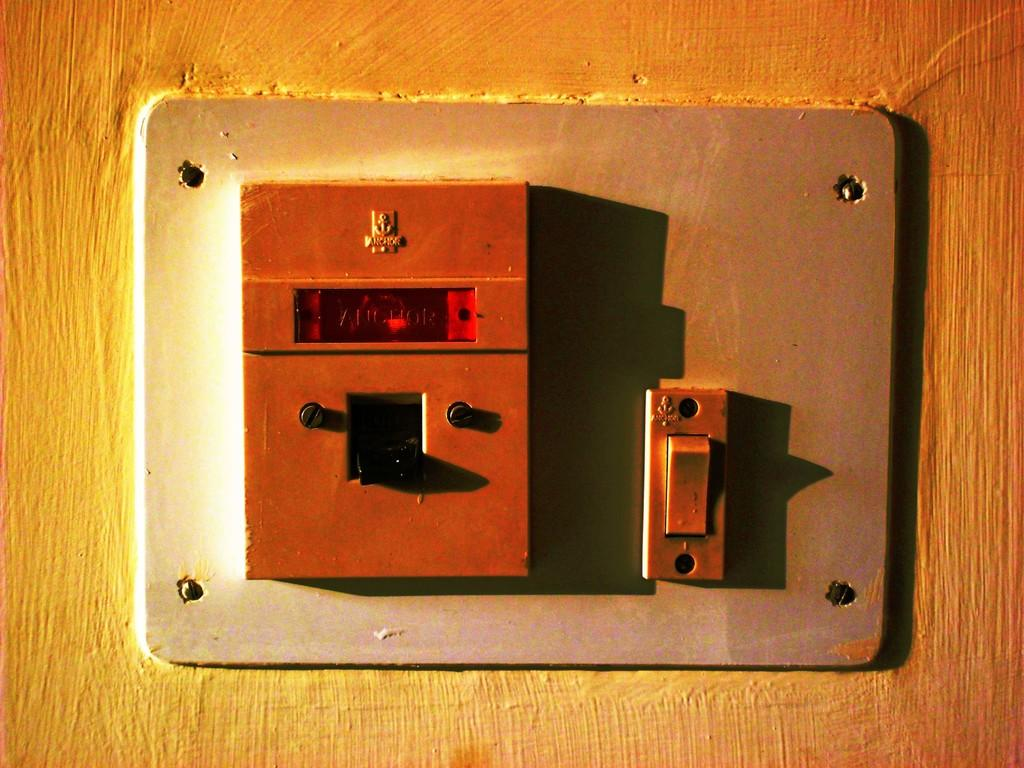What is the main subject in the image? There is a switch board in the image. Where is the switch board located? The switch board is on a wall. Is the dog using its elbow to turn on the switch board in the image? There is no dog or elbow present in the image; it only features a switch board on a wall. 